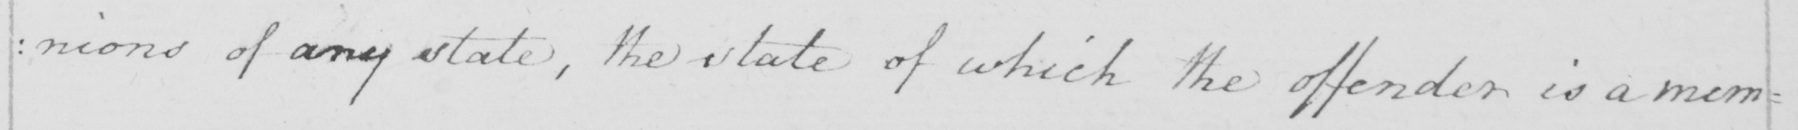Can you tell me what this handwritten text says? :nions of any state, the state of which the offender is a mem= 